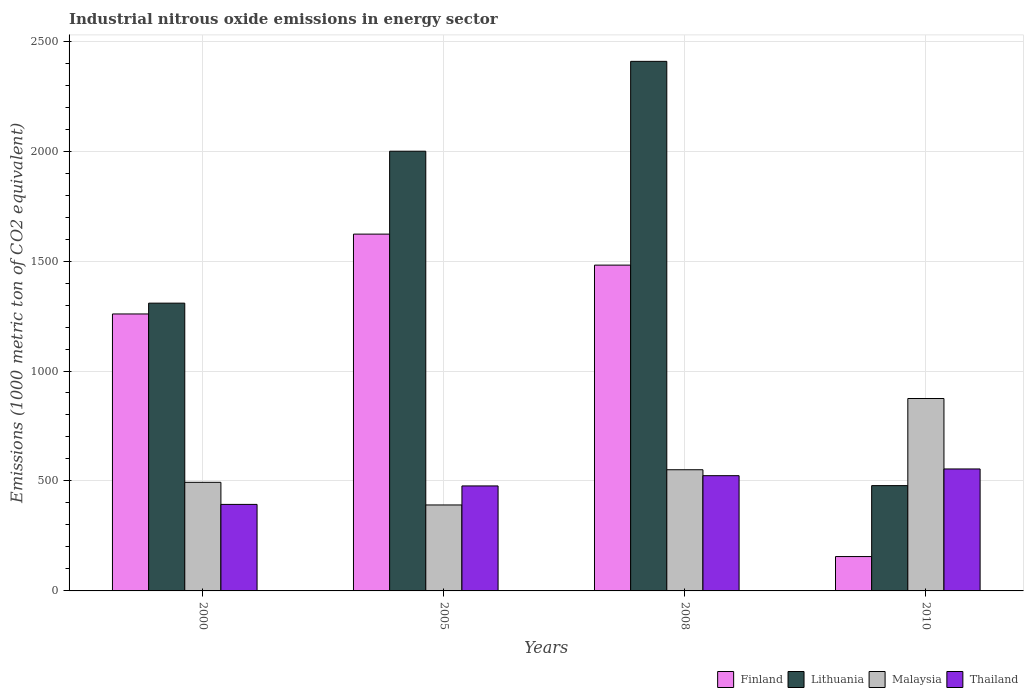How many groups of bars are there?
Your response must be concise. 4. Are the number of bars per tick equal to the number of legend labels?
Offer a very short reply. Yes. Are the number of bars on each tick of the X-axis equal?
Provide a succinct answer. Yes. How many bars are there on the 3rd tick from the right?
Keep it short and to the point. 4. What is the label of the 2nd group of bars from the left?
Keep it short and to the point. 2005. In how many cases, is the number of bars for a given year not equal to the number of legend labels?
Keep it short and to the point. 0. What is the amount of industrial nitrous oxide emitted in Malaysia in 2005?
Offer a very short reply. 390.9. Across all years, what is the maximum amount of industrial nitrous oxide emitted in Malaysia?
Offer a very short reply. 874.9. Across all years, what is the minimum amount of industrial nitrous oxide emitted in Lithuania?
Offer a very short reply. 478.8. In which year was the amount of industrial nitrous oxide emitted in Malaysia maximum?
Your answer should be very brief. 2010. In which year was the amount of industrial nitrous oxide emitted in Thailand minimum?
Ensure brevity in your answer.  2000. What is the total amount of industrial nitrous oxide emitted in Malaysia in the graph?
Provide a succinct answer. 2310.6. What is the difference between the amount of industrial nitrous oxide emitted in Finland in 2000 and that in 2008?
Provide a short and direct response. -222.1. What is the difference between the amount of industrial nitrous oxide emitted in Thailand in 2008 and the amount of industrial nitrous oxide emitted in Lithuania in 2005?
Provide a succinct answer. -1475.4. What is the average amount of industrial nitrous oxide emitted in Lithuania per year?
Your answer should be very brief. 1548.67. In the year 2008, what is the difference between the amount of industrial nitrous oxide emitted in Malaysia and amount of industrial nitrous oxide emitted in Lithuania?
Keep it short and to the point. -1857. What is the ratio of the amount of industrial nitrous oxide emitted in Malaysia in 2000 to that in 2008?
Offer a very short reply. 0.9. Is the difference between the amount of industrial nitrous oxide emitted in Malaysia in 2008 and 2010 greater than the difference between the amount of industrial nitrous oxide emitted in Lithuania in 2008 and 2010?
Provide a short and direct response. No. What is the difference between the highest and the second highest amount of industrial nitrous oxide emitted in Malaysia?
Ensure brevity in your answer.  323.9. What is the difference between the highest and the lowest amount of industrial nitrous oxide emitted in Malaysia?
Ensure brevity in your answer.  484. In how many years, is the amount of industrial nitrous oxide emitted in Lithuania greater than the average amount of industrial nitrous oxide emitted in Lithuania taken over all years?
Give a very brief answer. 2. Is the sum of the amount of industrial nitrous oxide emitted in Lithuania in 2005 and 2008 greater than the maximum amount of industrial nitrous oxide emitted in Thailand across all years?
Offer a very short reply. Yes. What does the 3rd bar from the left in 2008 represents?
Your response must be concise. Malaysia. What does the 3rd bar from the right in 2010 represents?
Provide a short and direct response. Lithuania. How many bars are there?
Your answer should be compact. 16. How many years are there in the graph?
Your answer should be very brief. 4. What is the difference between two consecutive major ticks on the Y-axis?
Make the answer very short. 500. Are the values on the major ticks of Y-axis written in scientific E-notation?
Make the answer very short. No. Does the graph contain any zero values?
Provide a succinct answer. No. Where does the legend appear in the graph?
Keep it short and to the point. Bottom right. How many legend labels are there?
Provide a succinct answer. 4. What is the title of the graph?
Give a very brief answer. Industrial nitrous oxide emissions in energy sector. What is the label or title of the X-axis?
Offer a very short reply. Years. What is the label or title of the Y-axis?
Your answer should be compact. Emissions (1000 metric ton of CO2 equivalent). What is the Emissions (1000 metric ton of CO2 equivalent) of Finland in 2000?
Make the answer very short. 1259.4. What is the Emissions (1000 metric ton of CO2 equivalent) in Lithuania in 2000?
Keep it short and to the point. 1308.5. What is the Emissions (1000 metric ton of CO2 equivalent) in Malaysia in 2000?
Your answer should be very brief. 493.8. What is the Emissions (1000 metric ton of CO2 equivalent) of Thailand in 2000?
Provide a succinct answer. 393.4. What is the Emissions (1000 metric ton of CO2 equivalent) in Finland in 2005?
Make the answer very short. 1622.4. What is the Emissions (1000 metric ton of CO2 equivalent) in Lithuania in 2005?
Your answer should be compact. 1999.4. What is the Emissions (1000 metric ton of CO2 equivalent) in Malaysia in 2005?
Make the answer very short. 390.9. What is the Emissions (1000 metric ton of CO2 equivalent) of Thailand in 2005?
Ensure brevity in your answer.  477.4. What is the Emissions (1000 metric ton of CO2 equivalent) of Finland in 2008?
Keep it short and to the point. 1481.5. What is the Emissions (1000 metric ton of CO2 equivalent) of Lithuania in 2008?
Provide a short and direct response. 2408. What is the Emissions (1000 metric ton of CO2 equivalent) in Malaysia in 2008?
Provide a short and direct response. 551. What is the Emissions (1000 metric ton of CO2 equivalent) of Thailand in 2008?
Ensure brevity in your answer.  524. What is the Emissions (1000 metric ton of CO2 equivalent) in Finland in 2010?
Offer a very short reply. 156.3. What is the Emissions (1000 metric ton of CO2 equivalent) in Lithuania in 2010?
Your answer should be very brief. 478.8. What is the Emissions (1000 metric ton of CO2 equivalent) of Malaysia in 2010?
Your answer should be compact. 874.9. What is the Emissions (1000 metric ton of CO2 equivalent) in Thailand in 2010?
Provide a succinct answer. 554.6. Across all years, what is the maximum Emissions (1000 metric ton of CO2 equivalent) in Finland?
Your response must be concise. 1622.4. Across all years, what is the maximum Emissions (1000 metric ton of CO2 equivalent) in Lithuania?
Keep it short and to the point. 2408. Across all years, what is the maximum Emissions (1000 metric ton of CO2 equivalent) of Malaysia?
Give a very brief answer. 874.9. Across all years, what is the maximum Emissions (1000 metric ton of CO2 equivalent) of Thailand?
Provide a short and direct response. 554.6. Across all years, what is the minimum Emissions (1000 metric ton of CO2 equivalent) of Finland?
Keep it short and to the point. 156.3. Across all years, what is the minimum Emissions (1000 metric ton of CO2 equivalent) in Lithuania?
Provide a short and direct response. 478.8. Across all years, what is the minimum Emissions (1000 metric ton of CO2 equivalent) of Malaysia?
Give a very brief answer. 390.9. Across all years, what is the minimum Emissions (1000 metric ton of CO2 equivalent) of Thailand?
Offer a very short reply. 393.4. What is the total Emissions (1000 metric ton of CO2 equivalent) of Finland in the graph?
Make the answer very short. 4519.6. What is the total Emissions (1000 metric ton of CO2 equivalent) of Lithuania in the graph?
Ensure brevity in your answer.  6194.7. What is the total Emissions (1000 metric ton of CO2 equivalent) of Malaysia in the graph?
Your answer should be very brief. 2310.6. What is the total Emissions (1000 metric ton of CO2 equivalent) in Thailand in the graph?
Make the answer very short. 1949.4. What is the difference between the Emissions (1000 metric ton of CO2 equivalent) in Finland in 2000 and that in 2005?
Your answer should be very brief. -363. What is the difference between the Emissions (1000 metric ton of CO2 equivalent) in Lithuania in 2000 and that in 2005?
Give a very brief answer. -690.9. What is the difference between the Emissions (1000 metric ton of CO2 equivalent) in Malaysia in 2000 and that in 2005?
Your answer should be very brief. 102.9. What is the difference between the Emissions (1000 metric ton of CO2 equivalent) in Thailand in 2000 and that in 2005?
Offer a terse response. -84. What is the difference between the Emissions (1000 metric ton of CO2 equivalent) of Finland in 2000 and that in 2008?
Your answer should be compact. -222.1. What is the difference between the Emissions (1000 metric ton of CO2 equivalent) of Lithuania in 2000 and that in 2008?
Your response must be concise. -1099.5. What is the difference between the Emissions (1000 metric ton of CO2 equivalent) of Malaysia in 2000 and that in 2008?
Offer a terse response. -57.2. What is the difference between the Emissions (1000 metric ton of CO2 equivalent) of Thailand in 2000 and that in 2008?
Make the answer very short. -130.6. What is the difference between the Emissions (1000 metric ton of CO2 equivalent) of Finland in 2000 and that in 2010?
Ensure brevity in your answer.  1103.1. What is the difference between the Emissions (1000 metric ton of CO2 equivalent) in Lithuania in 2000 and that in 2010?
Offer a very short reply. 829.7. What is the difference between the Emissions (1000 metric ton of CO2 equivalent) of Malaysia in 2000 and that in 2010?
Provide a succinct answer. -381.1. What is the difference between the Emissions (1000 metric ton of CO2 equivalent) in Thailand in 2000 and that in 2010?
Offer a terse response. -161.2. What is the difference between the Emissions (1000 metric ton of CO2 equivalent) of Finland in 2005 and that in 2008?
Your answer should be compact. 140.9. What is the difference between the Emissions (1000 metric ton of CO2 equivalent) of Lithuania in 2005 and that in 2008?
Keep it short and to the point. -408.6. What is the difference between the Emissions (1000 metric ton of CO2 equivalent) in Malaysia in 2005 and that in 2008?
Keep it short and to the point. -160.1. What is the difference between the Emissions (1000 metric ton of CO2 equivalent) of Thailand in 2005 and that in 2008?
Make the answer very short. -46.6. What is the difference between the Emissions (1000 metric ton of CO2 equivalent) of Finland in 2005 and that in 2010?
Ensure brevity in your answer.  1466.1. What is the difference between the Emissions (1000 metric ton of CO2 equivalent) in Lithuania in 2005 and that in 2010?
Provide a short and direct response. 1520.6. What is the difference between the Emissions (1000 metric ton of CO2 equivalent) in Malaysia in 2005 and that in 2010?
Keep it short and to the point. -484. What is the difference between the Emissions (1000 metric ton of CO2 equivalent) in Thailand in 2005 and that in 2010?
Give a very brief answer. -77.2. What is the difference between the Emissions (1000 metric ton of CO2 equivalent) in Finland in 2008 and that in 2010?
Ensure brevity in your answer.  1325.2. What is the difference between the Emissions (1000 metric ton of CO2 equivalent) of Lithuania in 2008 and that in 2010?
Offer a very short reply. 1929.2. What is the difference between the Emissions (1000 metric ton of CO2 equivalent) of Malaysia in 2008 and that in 2010?
Make the answer very short. -323.9. What is the difference between the Emissions (1000 metric ton of CO2 equivalent) of Thailand in 2008 and that in 2010?
Offer a very short reply. -30.6. What is the difference between the Emissions (1000 metric ton of CO2 equivalent) in Finland in 2000 and the Emissions (1000 metric ton of CO2 equivalent) in Lithuania in 2005?
Provide a succinct answer. -740. What is the difference between the Emissions (1000 metric ton of CO2 equivalent) in Finland in 2000 and the Emissions (1000 metric ton of CO2 equivalent) in Malaysia in 2005?
Offer a very short reply. 868.5. What is the difference between the Emissions (1000 metric ton of CO2 equivalent) in Finland in 2000 and the Emissions (1000 metric ton of CO2 equivalent) in Thailand in 2005?
Give a very brief answer. 782. What is the difference between the Emissions (1000 metric ton of CO2 equivalent) in Lithuania in 2000 and the Emissions (1000 metric ton of CO2 equivalent) in Malaysia in 2005?
Provide a short and direct response. 917.6. What is the difference between the Emissions (1000 metric ton of CO2 equivalent) in Lithuania in 2000 and the Emissions (1000 metric ton of CO2 equivalent) in Thailand in 2005?
Your response must be concise. 831.1. What is the difference between the Emissions (1000 metric ton of CO2 equivalent) of Finland in 2000 and the Emissions (1000 metric ton of CO2 equivalent) of Lithuania in 2008?
Make the answer very short. -1148.6. What is the difference between the Emissions (1000 metric ton of CO2 equivalent) of Finland in 2000 and the Emissions (1000 metric ton of CO2 equivalent) of Malaysia in 2008?
Give a very brief answer. 708.4. What is the difference between the Emissions (1000 metric ton of CO2 equivalent) in Finland in 2000 and the Emissions (1000 metric ton of CO2 equivalent) in Thailand in 2008?
Offer a terse response. 735.4. What is the difference between the Emissions (1000 metric ton of CO2 equivalent) in Lithuania in 2000 and the Emissions (1000 metric ton of CO2 equivalent) in Malaysia in 2008?
Keep it short and to the point. 757.5. What is the difference between the Emissions (1000 metric ton of CO2 equivalent) in Lithuania in 2000 and the Emissions (1000 metric ton of CO2 equivalent) in Thailand in 2008?
Your answer should be compact. 784.5. What is the difference between the Emissions (1000 metric ton of CO2 equivalent) of Malaysia in 2000 and the Emissions (1000 metric ton of CO2 equivalent) of Thailand in 2008?
Offer a terse response. -30.2. What is the difference between the Emissions (1000 metric ton of CO2 equivalent) in Finland in 2000 and the Emissions (1000 metric ton of CO2 equivalent) in Lithuania in 2010?
Give a very brief answer. 780.6. What is the difference between the Emissions (1000 metric ton of CO2 equivalent) of Finland in 2000 and the Emissions (1000 metric ton of CO2 equivalent) of Malaysia in 2010?
Keep it short and to the point. 384.5. What is the difference between the Emissions (1000 metric ton of CO2 equivalent) of Finland in 2000 and the Emissions (1000 metric ton of CO2 equivalent) of Thailand in 2010?
Provide a succinct answer. 704.8. What is the difference between the Emissions (1000 metric ton of CO2 equivalent) in Lithuania in 2000 and the Emissions (1000 metric ton of CO2 equivalent) in Malaysia in 2010?
Offer a very short reply. 433.6. What is the difference between the Emissions (1000 metric ton of CO2 equivalent) of Lithuania in 2000 and the Emissions (1000 metric ton of CO2 equivalent) of Thailand in 2010?
Make the answer very short. 753.9. What is the difference between the Emissions (1000 metric ton of CO2 equivalent) in Malaysia in 2000 and the Emissions (1000 metric ton of CO2 equivalent) in Thailand in 2010?
Give a very brief answer. -60.8. What is the difference between the Emissions (1000 metric ton of CO2 equivalent) of Finland in 2005 and the Emissions (1000 metric ton of CO2 equivalent) of Lithuania in 2008?
Your answer should be very brief. -785.6. What is the difference between the Emissions (1000 metric ton of CO2 equivalent) of Finland in 2005 and the Emissions (1000 metric ton of CO2 equivalent) of Malaysia in 2008?
Provide a succinct answer. 1071.4. What is the difference between the Emissions (1000 metric ton of CO2 equivalent) in Finland in 2005 and the Emissions (1000 metric ton of CO2 equivalent) in Thailand in 2008?
Your answer should be very brief. 1098.4. What is the difference between the Emissions (1000 metric ton of CO2 equivalent) of Lithuania in 2005 and the Emissions (1000 metric ton of CO2 equivalent) of Malaysia in 2008?
Provide a succinct answer. 1448.4. What is the difference between the Emissions (1000 metric ton of CO2 equivalent) in Lithuania in 2005 and the Emissions (1000 metric ton of CO2 equivalent) in Thailand in 2008?
Offer a very short reply. 1475.4. What is the difference between the Emissions (1000 metric ton of CO2 equivalent) in Malaysia in 2005 and the Emissions (1000 metric ton of CO2 equivalent) in Thailand in 2008?
Provide a short and direct response. -133.1. What is the difference between the Emissions (1000 metric ton of CO2 equivalent) of Finland in 2005 and the Emissions (1000 metric ton of CO2 equivalent) of Lithuania in 2010?
Keep it short and to the point. 1143.6. What is the difference between the Emissions (1000 metric ton of CO2 equivalent) in Finland in 2005 and the Emissions (1000 metric ton of CO2 equivalent) in Malaysia in 2010?
Keep it short and to the point. 747.5. What is the difference between the Emissions (1000 metric ton of CO2 equivalent) in Finland in 2005 and the Emissions (1000 metric ton of CO2 equivalent) in Thailand in 2010?
Your answer should be very brief. 1067.8. What is the difference between the Emissions (1000 metric ton of CO2 equivalent) of Lithuania in 2005 and the Emissions (1000 metric ton of CO2 equivalent) of Malaysia in 2010?
Give a very brief answer. 1124.5. What is the difference between the Emissions (1000 metric ton of CO2 equivalent) in Lithuania in 2005 and the Emissions (1000 metric ton of CO2 equivalent) in Thailand in 2010?
Give a very brief answer. 1444.8. What is the difference between the Emissions (1000 metric ton of CO2 equivalent) in Malaysia in 2005 and the Emissions (1000 metric ton of CO2 equivalent) in Thailand in 2010?
Offer a terse response. -163.7. What is the difference between the Emissions (1000 metric ton of CO2 equivalent) in Finland in 2008 and the Emissions (1000 metric ton of CO2 equivalent) in Lithuania in 2010?
Make the answer very short. 1002.7. What is the difference between the Emissions (1000 metric ton of CO2 equivalent) in Finland in 2008 and the Emissions (1000 metric ton of CO2 equivalent) in Malaysia in 2010?
Provide a short and direct response. 606.6. What is the difference between the Emissions (1000 metric ton of CO2 equivalent) of Finland in 2008 and the Emissions (1000 metric ton of CO2 equivalent) of Thailand in 2010?
Provide a succinct answer. 926.9. What is the difference between the Emissions (1000 metric ton of CO2 equivalent) of Lithuania in 2008 and the Emissions (1000 metric ton of CO2 equivalent) of Malaysia in 2010?
Offer a terse response. 1533.1. What is the difference between the Emissions (1000 metric ton of CO2 equivalent) of Lithuania in 2008 and the Emissions (1000 metric ton of CO2 equivalent) of Thailand in 2010?
Give a very brief answer. 1853.4. What is the average Emissions (1000 metric ton of CO2 equivalent) in Finland per year?
Offer a terse response. 1129.9. What is the average Emissions (1000 metric ton of CO2 equivalent) in Lithuania per year?
Your answer should be compact. 1548.67. What is the average Emissions (1000 metric ton of CO2 equivalent) in Malaysia per year?
Offer a terse response. 577.65. What is the average Emissions (1000 metric ton of CO2 equivalent) of Thailand per year?
Your answer should be compact. 487.35. In the year 2000, what is the difference between the Emissions (1000 metric ton of CO2 equivalent) in Finland and Emissions (1000 metric ton of CO2 equivalent) in Lithuania?
Provide a succinct answer. -49.1. In the year 2000, what is the difference between the Emissions (1000 metric ton of CO2 equivalent) of Finland and Emissions (1000 metric ton of CO2 equivalent) of Malaysia?
Offer a very short reply. 765.6. In the year 2000, what is the difference between the Emissions (1000 metric ton of CO2 equivalent) of Finland and Emissions (1000 metric ton of CO2 equivalent) of Thailand?
Your answer should be compact. 866. In the year 2000, what is the difference between the Emissions (1000 metric ton of CO2 equivalent) in Lithuania and Emissions (1000 metric ton of CO2 equivalent) in Malaysia?
Provide a succinct answer. 814.7. In the year 2000, what is the difference between the Emissions (1000 metric ton of CO2 equivalent) in Lithuania and Emissions (1000 metric ton of CO2 equivalent) in Thailand?
Keep it short and to the point. 915.1. In the year 2000, what is the difference between the Emissions (1000 metric ton of CO2 equivalent) of Malaysia and Emissions (1000 metric ton of CO2 equivalent) of Thailand?
Your answer should be very brief. 100.4. In the year 2005, what is the difference between the Emissions (1000 metric ton of CO2 equivalent) in Finland and Emissions (1000 metric ton of CO2 equivalent) in Lithuania?
Make the answer very short. -377. In the year 2005, what is the difference between the Emissions (1000 metric ton of CO2 equivalent) of Finland and Emissions (1000 metric ton of CO2 equivalent) of Malaysia?
Your answer should be compact. 1231.5. In the year 2005, what is the difference between the Emissions (1000 metric ton of CO2 equivalent) of Finland and Emissions (1000 metric ton of CO2 equivalent) of Thailand?
Your answer should be compact. 1145. In the year 2005, what is the difference between the Emissions (1000 metric ton of CO2 equivalent) of Lithuania and Emissions (1000 metric ton of CO2 equivalent) of Malaysia?
Your answer should be compact. 1608.5. In the year 2005, what is the difference between the Emissions (1000 metric ton of CO2 equivalent) of Lithuania and Emissions (1000 metric ton of CO2 equivalent) of Thailand?
Make the answer very short. 1522. In the year 2005, what is the difference between the Emissions (1000 metric ton of CO2 equivalent) in Malaysia and Emissions (1000 metric ton of CO2 equivalent) in Thailand?
Your response must be concise. -86.5. In the year 2008, what is the difference between the Emissions (1000 metric ton of CO2 equivalent) in Finland and Emissions (1000 metric ton of CO2 equivalent) in Lithuania?
Ensure brevity in your answer.  -926.5. In the year 2008, what is the difference between the Emissions (1000 metric ton of CO2 equivalent) of Finland and Emissions (1000 metric ton of CO2 equivalent) of Malaysia?
Keep it short and to the point. 930.5. In the year 2008, what is the difference between the Emissions (1000 metric ton of CO2 equivalent) of Finland and Emissions (1000 metric ton of CO2 equivalent) of Thailand?
Offer a very short reply. 957.5. In the year 2008, what is the difference between the Emissions (1000 metric ton of CO2 equivalent) in Lithuania and Emissions (1000 metric ton of CO2 equivalent) in Malaysia?
Provide a succinct answer. 1857. In the year 2008, what is the difference between the Emissions (1000 metric ton of CO2 equivalent) of Lithuania and Emissions (1000 metric ton of CO2 equivalent) of Thailand?
Provide a succinct answer. 1884. In the year 2010, what is the difference between the Emissions (1000 metric ton of CO2 equivalent) in Finland and Emissions (1000 metric ton of CO2 equivalent) in Lithuania?
Provide a succinct answer. -322.5. In the year 2010, what is the difference between the Emissions (1000 metric ton of CO2 equivalent) of Finland and Emissions (1000 metric ton of CO2 equivalent) of Malaysia?
Ensure brevity in your answer.  -718.6. In the year 2010, what is the difference between the Emissions (1000 metric ton of CO2 equivalent) of Finland and Emissions (1000 metric ton of CO2 equivalent) of Thailand?
Offer a very short reply. -398.3. In the year 2010, what is the difference between the Emissions (1000 metric ton of CO2 equivalent) of Lithuania and Emissions (1000 metric ton of CO2 equivalent) of Malaysia?
Your answer should be very brief. -396.1. In the year 2010, what is the difference between the Emissions (1000 metric ton of CO2 equivalent) in Lithuania and Emissions (1000 metric ton of CO2 equivalent) in Thailand?
Offer a very short reply. -75.8. In the year 2010, what is the difference between the Emissions (1000 metric ton of CO2 equivalent) of Malaysia and Emissions (1000 metric ton of CO2 equivalent) of Thailand?
Offer a very short reply. 320.3. What is the ratio of the Emissions (1000 metric ton of CO2 equivalent) of Finland in 2000 to that in 2005?
Your answer should be compact. 0.78. What is the ratio of the Emissions (1000 metric ton of CO2 equivalent) of Lithuania in 2000 to that in 2005?
Offer a terse response. 0.65. What is the ratio of the Emissions (1000 metric ton of CO2 equivalent) of Malaysia in 2000 to that in 2005?
Ensure brevity in your answer.  1.26. What is the ratio of the Emissions (1000 metric ton of CO2 equivalent) in Thailand in 2000 to that in 2005?
Give a very brief answer. 0.82. What is the ratio of the Emissions (1000 metric ton of CO2 equivalent) in Finland in 2000 to that in 2008?
Offer a very short reply. 0.85. What is the ratio of the Emissions (1000 metric ton of CO2 equivalent) of Lithuania in 2000 to that in 2008?
Provide a short and direct response. 0.54. What is the ratio of the Emissions (1000 metric ton of CO2 equivalent) of Malaysia in 2000 to that in 2008?
Provide a short and direct response. 0.9. What is the ratio of the Emissions (1000 metric ton of CO2 equivalent) in Thailand in 2000 to that in 2008?
Offer a very short reply. 0.75. What is the ratio of the Emissions (1000 metric ton of CO2 equivalent) in Finland in 2000 to that in 2010?
Provide a short and direct response. 8.06. What is the ratio of the Emissions (1000 metric ton of CO2 equivalent) of Lithuania in 2000 to that in 2010?
Offer a terse response. 2.73. What is the ratio of the Emissions (1000 metric ton of CO2 equivalent) of Malaysia in 2000 to that in 2010?
Offer a terse response. 0.56. What is the ratio of the Emissions (1000 metric ton of CO2 equivalent) of Thailand in 2000 to that in 2010?
Your response must be concise. 0.71. What is the ratio of the Emissions (1000 metric ton of CO2 equivalent) in Finland in 2005 to that in 2008?
Provide a short and direct response. 1.1. What is the ratio of the Emissions (1000 metric ton of CO2 equivalent) of Lithuania in 2005 to that in 2008?
Offer a very short reply. 0.83. What is the ratio of the Emissions (1000 metric ton of CO2 equivalent) in Malaysia in 2005 to that in 2008?
Your answer should be compact. 0.71. What is the ratio of the Emissions (1000 metric ton of CO2 equivalent) in Thailand in 2005 to that in 2008?
Ensure brevity in your answer.  0.91. What is the ratio of the Emissions (1000 metric ton of CO2 equivalent) in Finland in 2005 to that in 2010?
Give a very brief answer. 10.38. What is the ratio of the Emissions (1000 metric ton of CO2 equivalent) of Lithuania in 2005 to that in 2010?
Provide a short and direct response. 4.18. What is the ratio of the Emissions (1000 metric ton of CO2 equivalent) of Malaysia in 2005 to that in 2010?
Give a very brief answer. 0.45. What is the ratio of the Emissions (1000 metric ton of CO2 equivalent) in Thailand in 2005 to that in 2010?
Your answer should be compact. 0.86. What is the ratio of the Emissions (1000 metric ton of CO2 equivalent) in Finland in 2008 to that in 2010?
Offer a very short reply. 9.48. What is the ratio of the Emissions (1000 metric ton of CO2 equivalent) of Lithuania in 2008 to that in 2010?
Keep it short and to the point. 5.03. What is the ratio of the Emissions (1000 metric ton of CO2 equivalent) in Malaysia in 2008 to that in 2010?
Offer a very short reply. 0.63. What is the ratio of the Emissions (1000 metric ton of CO2 equivalent) of Thailand in 2008 to that in 2010?
Give a very brief answer. 0.94. What is the difference between the highest and the second highest Emissions (1000 metric ton of CO2 equivalent) of Finland?
Your response must be concise. 140.9. What is the difference between the highest and the second highest Emissions (1000 metric ton of CO2 equivalent) of Lithuania?
Keep it short and to the point. 408.6. What is the difference between the highest and the second highest Emissions (1000 metric ton of CO2 equivalent) in Malaysia?
Offer a terse response. 323.9. What is the difference between the highest and the second highest Emissions (1000 metric ton of CO2 equivalent) of Thailand?
Your response must be concise. 30.6. What is the difference between the highest and the lowest Emissions (1000 metric ton of CO2 equivalent) of Finland?
Your answer should be compact. 1466.1. What is the difference between the highest and the lowest Emissions (1000 metric ton of CO2 equivalent) in Lithuania?
Keep it short and to the point. 1929.2. What is the difference between the highest and the lowest Emissions (1000 metric ton of CO2 equivalent) of Malaysia?
Offer a terse response. 484. What is the difference between the highest and the lowest Emissions (1000 metric ton of CO2 equivalent) in Thailand?
Give a very brief answer. 161.2. 